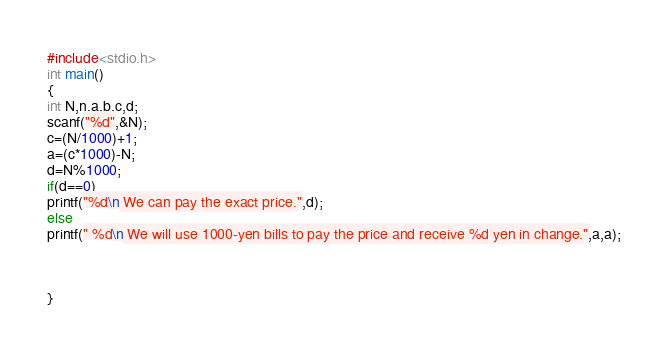Convert code to text. <code><loc_0><loc_0><loc_500><loc_500><_C_>#include<stdio.h>
int main()
{
int N,n,a,b,c,d;
scanf("%d",&N);
c=(N/1000)+1;
a=(c*1000)-N;
d=N%1000;
if(d==0)
printf("%d\n We can pay the exact price.",d);
else
printf(" %d\n We will use 1000-yen bills to pay the price and receive %d yen in change.",a,a);



}</code> 